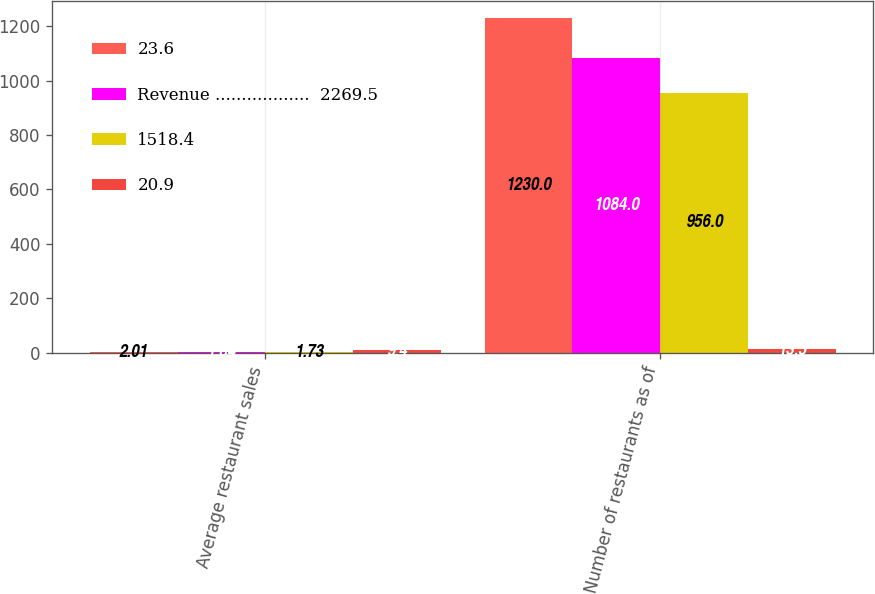<chart> <loc_0><loc_0><loc_500><loc_500><stacked_bar_chart><ecel><fcel>Average restaurant sales<fcel>Number of restaurants as of<nl><fcel>23.6<fcel>2.01<fcel>1230<nl><fcel>Revenue ..................  2269.5<fcel>1.84<fcel>1084<nl><fcel>1518.4<fcel>1.73<fcel>956<nl><fcel>20.9<fcel>9.4<fcel>13.5<nl></chart> 